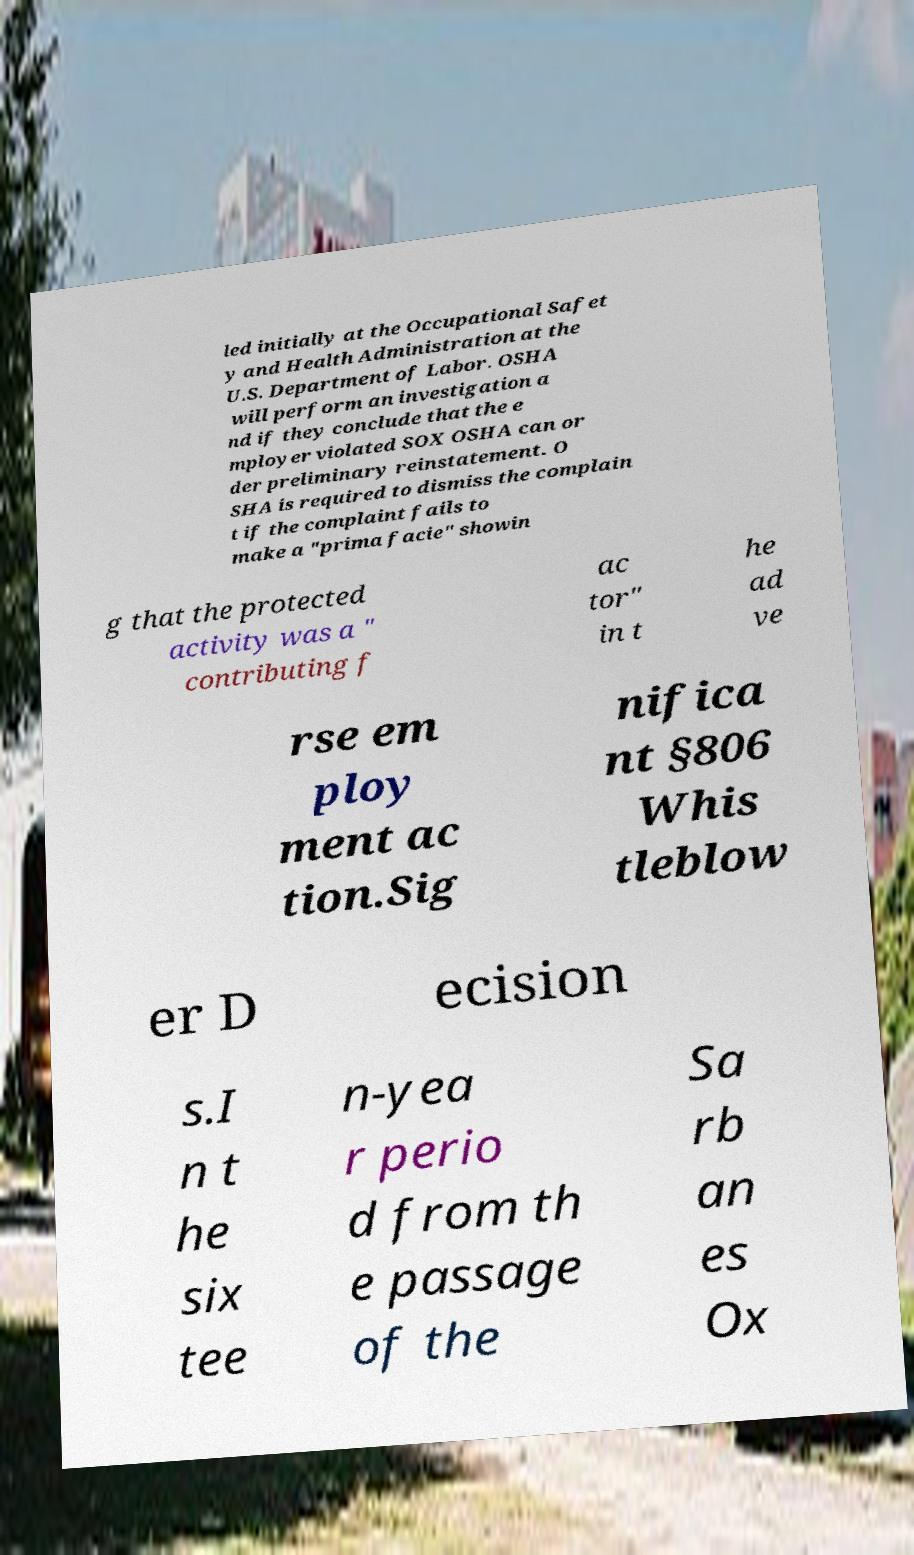Could you extract and type out the text from this image? led initially at the Occupational Safet y and Health Administration at the U.S. Department of Labor. OSHA will perform an investigation a nd if they conclude that the e mployer violated SOX OSHA can or der preliminary reinstatement. O SHA is required to dismiss the complain t if the complaint fails to make a "prima facie" showin g that the protected activity was a " contributing f ac tor" in t he ad ve rse em ploy ment ac tion.Sig nifica nt §806 Whis tleblow er D ecision s.I n t he six tee n-yea r perio d from th e passage of the Sa rb an es Ox 